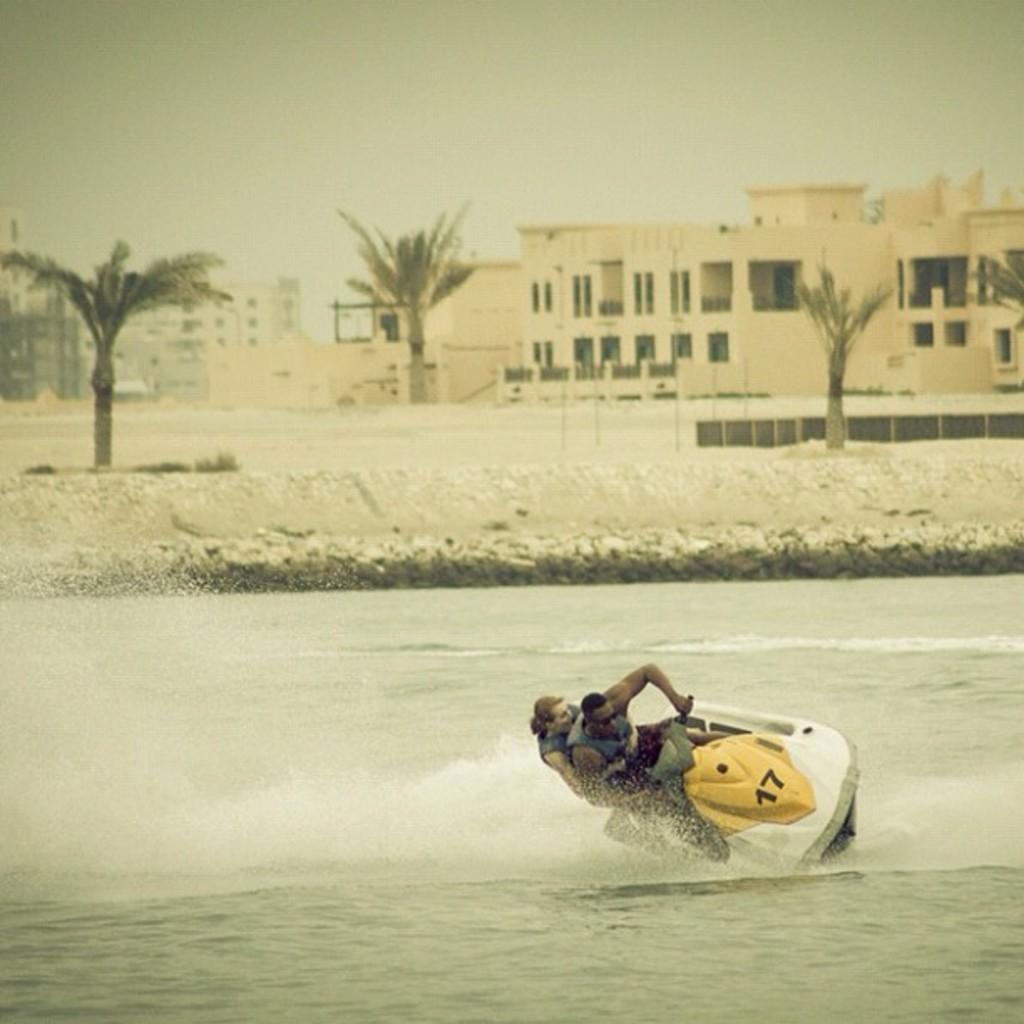How many people are on the boat in the image? There are two persons riding on a boat in the image. Where is the boat located? The boat is in the water. What can be seen in the background of the image? Buildings and trees are visible in the image. What is visible at the top of the image? The sky is visible at the top of the image. What type of rod is being used by the secretary in the image? There is no secretary or rod present in the image. 